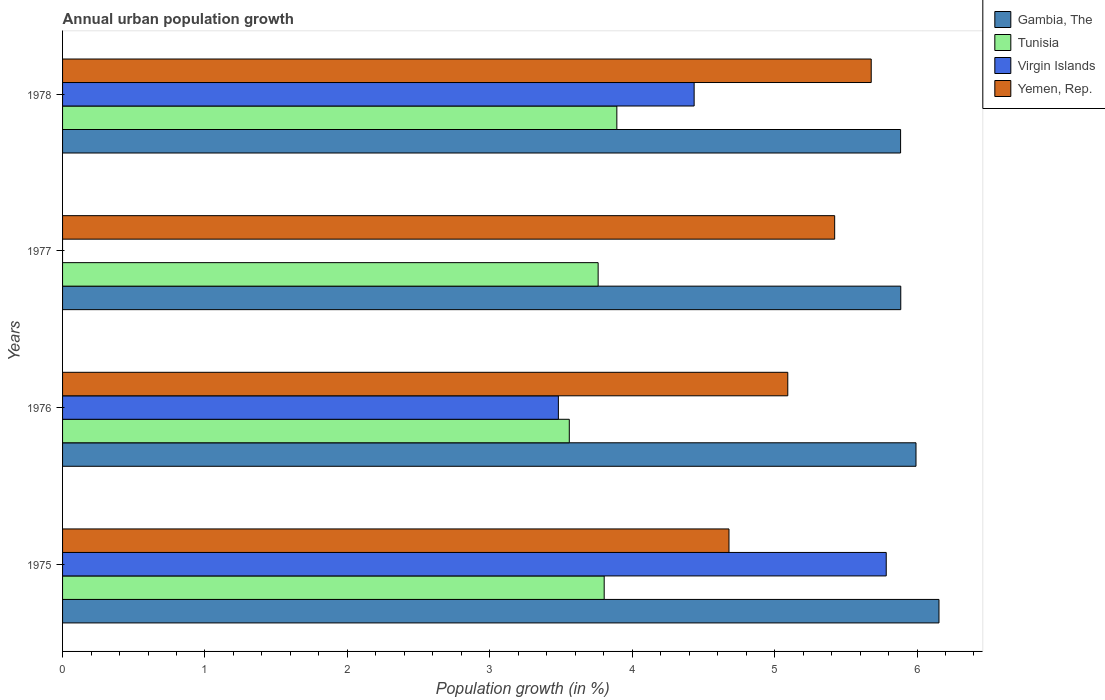Are the number of bars per tick equal to the number of legend labels?
Offer a very short reply. No. How many bars are there on the 1st tick from the top?
Your response must be concise. 4. How many bars are there on the 4th tick from the bottom?
Your answer should be very brief. 4. What is the label of the 4th group of bars from the top?
Ensure brevity in your answer.  1975. What is the percentage of urban population growth in Gambia, The in 1978?
Your response must be concise. 5.88. Across all years, what is the maximum percentage of urban population growth in Tunisia?
Offer a terse response. 3.89. Across all years, what is the minimum percentage of urban population growth in Tunisia?
Give a very brief answer. 3.56. In which year was the percentage of urban population growth in Yemen, Rep. maximum?
Offer a terse response. 1978. What is the total percentage of urban population growth in Gambia, The in the graph?
Keep it short and to the point. 23.92. What is the difference between the percentage of urban population growth in Tunisia in 1975 and that in 1977?
Your answer should be compact. 0.04. What is the difference between the percentage of urban population growth in Virgin Islands in 1978 and the percentage of urban population growth in Yemen, Rep. in 1976?
Give a very brief answer. -0.66. What is the average percentage of urban population growth in Tunisia per year?
Give a very brief answer. 3.75. In the year 1978, what is the difference between the percentage of urban population growth in Yemen, Rep. and percentage of urban population growth in Gambia, The?
Ensure brevity in your answer.  -0.21. In how many years, is the percentage of urban population growth in Yemen, Rep. greater than 6 %?
Ensure brevity in your answer.  0. What is the ratio of the percentage of urban population growth in Gambia, The in 1976 to that in 1977?
Provide a short and direct response. 1.02. Is the percentage of urban population growth in Yemen, Rep. in 1975 less than that in 1978?
Make the answer very short. Yes. What is the difference between the highest and the second highest percentage of urban population growth in Gambia, The?
Ensure brevity in your answer.  0.16. What is the difference between the highest and the lowest percentage of urban population growth in Virgin Islands?
Your answer should be very brief. 5.78. Is the sum of the percentage of urban population growth in Gambia, The in 1977 and 1978 greater than the maximum percentage of urban population growth in Yemen, Rep. across all years?
Your answer should be compact. Yes. Is it the case that in every year, the sum of the percentage of urban population growth in Yemen, Rep. and percentage of urban population growth in Tunisia is greater than the sum of percentage of urban population growth in Gambia, The and percentage of urban population growth in Virgin Islands?
Your answer should be very brief. No. Is it the case that in every year, the sum of the percentage of urban population growth in Yemen, Rep. and percentage of urban population growth in Virgin Islands is greater than the percentage of urban population growth in Gambia, The?
Give a very brief answer. No. Where does the legend appear in the graph?
Make the answer very short. Top right. How many legend labels are there?
Keep it short and to the point. 4. What is the title of the graph?
Provide a short and direct response. Annual urban population growth. What is the label or title of the X-axis?
Your answer should be compact. Population growth (in %). What is the Population growth (in %) of Gambia, The in 1975?
Your answer should be very brief. 6.15. What is the Population growth (in %) of Tunisia in 1975?
Offer a very short reply. 3.8. What is the Population growth (in %) in Virgin Islands in 1975?
Make the answer very short. 5.78. What is the Population growth (in %) of Yemen, Rep. in 1975?
Your answer should be compact. 4.68. What is the Population growth (in %) in Gambia, The in 1976?
Offer a very short reply. 5.99. What is the Population growth (in %) in Tunisia in 1976?
Your answer should be compact. 3.56. What is the Population growth (in %) of Virgin Islands in 1976?
Provide a short and direct response. 3.48. What is the Population growth (in %) in Yemen, Rep. in 1976?
Give a very brief answer. 5.09. What is the Population growth (in %) of Gambia, The in 1977?
Keep it short and to the point. 5.89. What is the Population growth (in %) in Tunisia in 1977?
Your answer should be very brief. 3.76. What is the Population growth (in %) of Virgin Islands in 1977?
Provide a short and direct response. 0. What is the Population growth (in %) of Yemen, Rep. in 1977?
Offer a terse response. 5.42. What is the Population growth (in %) in Gambia, The in 1978?
Your answer should be very brief. 5.88. What is the Population growth (in %) in Tunisia in 1978?
Your answer should be compact. 3.89. What is the Population growth (in %) of Virgin Islands in 1978?
Your response must be concise. 4.44. What is the Population growth (in %) of Yemen, Rep. in 1978?
Offer a terse response. 5.68. Across all years, what is the maximum Population growth (in %) of Gambia, The?
Provide a succinct answer. 6.15. Across all years, what is the maximum Population growth (in %) of Tunisia?
Ensure brevity in your answer.  3.89. Across all years, what is the maximum Population growth (in %) in Virgin Islands?
Your answer should be very brief. 5.78. Across all years, what is the maximum Population growth (in %) of Yemen, Rep.?
Your response must be concise. 5.68. Across all years, what is the minimum Population growth (in %) in Gambia, The?
Offer a terse response. 5.88. Across all years, what is the minimum Population growth (in %) in Tunisia?
Your answer should be compact. 3.56. Across all years, what is the minimum Population growth (in %) of Virgin Islands?
Provide a succinct answer. 0. Across all years, what is the minimum Population growth (in %) of Yemen, Rep.?
Provide a short and direct response. 4.68. What is the total Population growth (in %) of Gambia, The in the graph?
Provide a short and direct response. 23.92. What is the total Population growth (in %) in Tunisia in the graph?
Your answer should be compact. 15.02. What is the total Population growth (in %) of Virgin Islands in the graph?
Ensure brevity in your answer.  13.7. What is the total Population growth (in %) of Yemen, Rep. in the graph?
Provide a succinct answer. 20.87. What is the difference between the Population growth (in %) of Gambia, The in 1975 and that in 1976?
Provide a succinct answer. 0.16. What is the difference between the Population growth (in %) in Tunisia in 1975 and that in 1976?
Ensure brevity in your answer.  0.24. What is the difference between the Population growth (in %) in Virgin Islands in 1975 and that in 1976?
Ensure brevity in your answer.  2.3. What is the difference between the Population growth (in %) of Yemen, Rep. in 1975 and that in 1976?
Provide a short and direct response. -0.41. What is the difference between the Population growth (in %) of Gambia, The in 1975 and that in 1977?
Your answer should be compact. 0.27. What is the difference between the Population growth (in %) in Tunisia in 1975 and that in 1977?
Offer a terse response. 0.04. What is the difference between the Population growth (in %) of Yemen, Rep. in 1975 and that in 1977?
Provide a succinct answer. -0.74. What is the difference between the Population growth (in %) of Gambia, The in 1975 and that in 1978?
Give a very brief answer. 0.27. What is the difference between the Population growth (in %) in Tunisia in 1975 and that in 1978?
Make the answer very short. -0.09. What is the difference between the Population growth (in %) of Virgin Islands in 1975 and that in 1978?
Offer a very short reply. 1.35. What is the difference between the Population growth (in %) of Yemen, Rep. in 1975 and that in 1978?
Make the answer very short. -1. What is the difference between the Population growth (in %) of Gambia, The in 1976 and that in 1977?
Your answer should be compact. 0.11. What is the difference between the Population growth (in %) in Tunisia in 1976 and that in 1977?
Your answer should be compact. -0.2. What is the difference between the Population growth (in %) of Yemen, Rep. in 1976 and that in 1977?
Your response must be concise. -0.33. What is the difference between the Population growth (in %) of Gambia, The in 1976 and that in 1978?
Offer a very short reply. 0.11. What is the difference between the Population growth (in %) of Tunisia in 1976 and that in 1978?
Keep it short and to the point. -0.33. What is the difference between the Population growth (in %) in Virgin Islands in 1976 and that in 1978?
Ensure brevity in your answer.  -0.95. What is the difference between the Population growth (in %) of Yemen, Rep. in 1976 and that in 1978?
Give a very brief answer. -0.59. What is the difference between the Population growth (in %) in Gambia, The in 1977 and that in 1978?
Provide a short and direct response. 0. What is the difference between the Population growth (in %) of Tunisia in 1977 and that in 1978?
Your response must be concise. -0.13. What is the difference between the Population growth (in %) in Yemen, Rep. in 1977 and that in 1978?
Your answer should be compact. -0.26. What is the difference between the Population growth (in %) in Gambia, The in 1975 and the Population growth (in %) in Tunisia in 1976?
Provide a short and direct response. 2.6. What is the difference between the Population growth (in %) of Gambia, The in 1975 and the Population growth (in %) of Virgin Islands in 1976?
Offer a terse response. 2.67. What is the difference between the Population growth (in %) of Gambia, The in 1975 and the Population growth (in %) of Yemen, Rep. in 1976?
Your answer should be very brief. 1.06. What is the difference between the Population growth (in %) in Tunisia in 1975 and the Population growth (in %) in Virgin Islands in 1976?
Your response must be concise. 0.32. What is the difference between the Population growth (in %) of Tunisia in 1975 and the Population growth (in %) of Yemen, Rep. in 1976?
Your answer should be very brief. -1.29. What is the difference between the Population growth (in %) in Virgin Islands in 1975 and the Population growth (in %) in Yemen, Rep. in 1976?
Offer a terse response. 0.69. What is the difference between the Population growth (in %) of Gambia, The in 1975 and the Population growth (in %) of Tunisia in 1977?
Your response must be concise. 2.39. What is the difference between the Population growth (in %) in Gambia, The in 1975 and the Population growth (in %) in Yemen, Rep. in 1977?
Provide a succinct answer. 0.73. What is the difference between the Population growth (in %) in Tunisia in 1975 and the Population growth (in %) in Yemen, Rep. in 1977?
Provide a short and direct response. -1.62. What is the difference between the Population growth (in %) of Virgin Islands in 1975 and the Population growth (in %) of Yemen, Rep. in 1977?
Provide a succinct answer. 0.36. What is the difference between the Population growth (in %) of Gambia, The in 1975 and the Population growth (in %) of Tunisia in 1978?
Ensure brevity in your answer.  2.26. What is the difference between the Population growth (in %) in Gambia, The in 1975 and the Population growth (in %) in Virgin Islands in 1978?
Offer a terse response. 1.72. What is the difference between the Population growth (in %) of Gambia, The in 1975 and the Population growth (in %) of Yemen, Rep. in 1978?
Ensure brevity in your answer.  0.48. What is the difference between the Population growth (in %) of Tunisia in 1975 and the Population growth (in %) of Virgin Islands in 1978?
Provide a succinct answer. -0.63. What is the difference between the Population growth (in %) of Tunisia in 1975 and the Population growth (in %) of Yemen, Rep. in 1978?
Your answer should be very brief. -1.88. What is the difference between the Population growth (in %) of Virgin Islands in 1975 and the Population growth (in %) of Yemen, Rep. in 1978?
Ensure brevity in your answer.  0.11. What is the difference between the Population growth (in %) of Gambia, The in 1976 and the Population growth (in %) of Tunisia in 1977?
Provide a short and direct response. 2.23. What is the difference between the Population growth (in %) in Gambia, The in 1976 and the Population growth (in %) in Yemen, Rep. in 1977?
Keep it short and to the point. 0.57. What is the difference between the Population growth (in %) in Tunisia in 1976 and the Population growth (in %) in Yemen, Rep. in 1977?
Offer a terse response. -1.86. What is the difference between the Population growth (in %) of Virgin Islands in 1976 and the Population growth (in %) of Yemen, Rep. in 1977?
Offer a terse response. -1.94. What is the difference between the Population growth (in %) of Gambia, The in 1976 and the Population growth (in %) of Tunisia in 1978?
Your answer should be very brief. 2.1. What is the difference between the Population growth (in %) in Gambia, The in 1976 and the Population growth (in %) in Virgin Islands in 1978?
Give a very brief answer. 1.56. What is the difference between the Population growth (in %) in Gambia, The in 1976 and the Population growth (in %) in Yemen, Rep. in 1978?
Offer a very short reply. 0.31. What is the difference between the Population growth (in %) of Tunisia in 1976 and the Population growth (in %) of Virgin Islands in 1978?
Offer a terse response. -0.88. What is the difference between the Population growth (in %) of Tunisia in 1976 and the Population growth (in %) of Yemen, Rep. in 1978?
Offer a very short reply. -2.12. What is the difference between the Population growth (in %) of Virgin Islands in 1976 and the Population growth (in %) of Yemen, Rep. in 1978?
Make the answer very short. -2.2. What is the difference between the Population growth (in %) in Gambia, The in 1977 and the Population growth (in %) in Tunisia in 1978?
Offer a terse response. 1.99. What is the difference between the Population growth (in %) in Gambia, The in 1977 and the Population growth (in %) in Virgin Islands in 1978?
Your answer should be compact. 1.45. What is the difference between the Population growth (in %) in Gambia, The in 1977 and the Population growth (in %) in Yemen, Rep. in 1978?
Offer a very short reply. 0.21. What is the difference between the Population growth (in %) of Tunisia in 1977 and the Population growth (in %) of Virgin Islands in 1978?
Offer a very short reply. -0.67. What is the difference between the Population growth (in %) of Tunisia in 1977 and the Population growth (in %) of Yemen, Rep. in 1978?
Make the answer very short. -1.92. What is the average Population growth (in %) of Gambia, The per year?
Offer a very short reply. 5.98. What is the average Population growth (in %) in Tunisia per year?
Your answer should be compact. 3.75. What is the average Population growth (in %) of Virgin Islands per year?
Offer a very short reply. 3.43. What is the average Population growth (in %) of Yemen, Rep. per year?
Your answer should be compact. 5.22. In the year 1975, what is the difference between the Population growth (in %) of Gambia, The and Population growth (in %) of Tunisia?
Your answer should be compact. 2.35. In the year 1975, what is the difference between the Population growth (in %) of Gambia, The and Population growth (in %) of Virgin Islands?
Provide a succinct answer. 0.37. In the year 1975, what is the difference between the Population growth (in %) of Gambia, The and Population growth (in %) of Yemen, Rep.?
Make the answer very short. 1.47. In the year 1975, what is the difference between the Population growth (in %) of Tunisia and Population growth (in %) of Virgin Islands?
Give a very brief answer. -1.98. In the year 1975, what is the difference between the Population growth (in %) of Tunisia and Population growth (in %) of Yemen, Rep.?
Ensure brevity in your answer.  -0.88. In the year 1975, what is the difference between the Population growth (in %) in Virgin Islands and Population growth (in %) in Yemen, Rep.?
Provide a succinct answer. 1.1. In the year 1976, what is the difference between the Population growth (in %) in Gambia, The and Population growth (in %) in Tunisia?
Your answer should be very brief. 2.43. In the year 1976, what is the difference between the Population growth (in %) in Gambia, The and Population growth (in %) in Virgin Islands?
Provide a short and direct response. 2.51. In the year 1976, what is the difference between the Population growth (in %) in Gambia, The and Population growth (in %) in Yemen, Rep.?
Ensure brevity in your answer.  0.9. In the year 1976, what is the difference between the Population growth (in %) in Tunisia and Population growth (in %) in Virgin Islands?
Keep it short and to the point. 0.08. In the year 1976, what is the difference between the Population growth (in %) of Tunisia and Population growth (in %) of Yemen, Rep.?
Your response must be concise. -1.53. In the year 1976, what is the difference between the Population growth (in %) of Virgin Islands and Population growth (in %) of Yemen, Rep.?
Make the answer very short. -1.61. In the year 1977, what is the difference between the Population growth (in %) in Gambia, The and Population growth (in %) in Tunisia?
Provide a short and direct response. 2.12. In the year 1977, what is the difference between the Population growth (in %) of Gambia, The and Population growth (in %) of Yemen, Rep.?
Offer a very short reply. 0.46. In the year 1977, what is the difference between the Population growth (in %) in Tunisia and Population growth (in %) in Yemen, Rep.?
Make the answer very short. -1.66. In the year 1978, what is the difference between the Population growth (in %) in Gambia, The and Population growth (in %) in Tunisia?
Your response must be concise. 1.99. In the year 1978, what is the difference between the Population growth (in %) in Gambia, The and Population growth (in %) in Virgin Islands?
Offer a very short reply. 1.45. In the year 1978, what is the difference between the Population growth (in %) in Gambia, The and Population growth (in %) in Yemen, Rep.?
Give a very brief answer. 0.21. In the year 1978, what is the difference between the Population growth (in %) of Tunisia and Population growth (in %) of Virgin Islands?
Ensure brevity in your answer.  -0.54. In the year 1978, what is the difference between the Population growth (in %) of Tunisia and Population growth (in %) of Yemen, Rep.?
Offer a very short reply. -1.79. In the year 1978, what is the difference between the Population growth (in %) in Virgin Islands and Population growth (in %) in Yemen, Rep.?
Offer a terse response. -1.24. What is the ratio of the Population growth (in %) of Gambia, The in 1975 to that in 1976?
Offer a terse response. 1.03. What is the ratio of the Population growth (in %) in Tunisia in 1975 to that in 1976?
Your answer should be very brief. 1.07. What is the ratio of the Population growth (in %) of Virgin Islands in 1975 to that in 1976?
Your response must be concise. 1.66. What is the ratio of the Population growth (in %) in Yemen, Rep. in 1975 to that in 1976?
Give a very brief answer. 0.92. What is the ratio of the Population growth (in %) of Gambia, The in 1975 to that in 1977?
Your response must be concise. 1.05. What is the ratio of the Population growth (in %) in Tunisia in 1975 to that in 1977?
Offer a very short reply. 1.01. What is the ratio of the Population growth (in %) of Yemen, Rep. in 1975 to that in 1977?
Give a very brief answer. 0.86. What is the ratio of the Population growth (in %) in Gambia, The in 1975 to that in 1978?
Offer a very short reply. 1.05. What is the ratio of the Population growth (in %) in Tunisia in 1975 to that in 1978?
Your answer should be very brief. 0.98. What is the ratio of the Population growth (in %) in Virgin Islands in 1975 to that in 1978?
Your response must be concise. 1.3. What is the ratio of the Population growth (in %) of Yemen, Rep. in 1975 to that in 1978?
Provide a succinct answer. 0.82. What is the ratio of the Population growth (in %) in Gambia, The in 1976 to that in 1977?
Make the answer very short. 1.02. What is the ratio of the Population growth (in %) in Tunisia in 1976 to that in 1977?
Provide a short and direct response. 0.95. What is the ratio of the Population growth (in %) of Yemen, Rep. in 1976 to that in 1977?
Your response must be concise. 0.94. What is the ratio of the Population growth (in %) in Gambia, The in 1976 to that in 1978?
Provide a succinct answer. 1.02. What is the ratio of the Population growth (in %) of Tunisia in 1976 to that in 1978?
Offer a terse response. 0.91. What is the ratio of the Population growth (in %) of Virgin Islands in 1976 to that in 1978?
Your answer should be compact. 0.79. What is the ratio of the Population growth (in %) in Yemen, Rep. in 1976 to that in 1978?
Provide a short and direct response. 0.9. What is the ratio of the Population growth (in %) in Gambia, The in 1977 to that in 1978?
Offer a terse response. 1. What is the ratio of the Population growth (in %) of Tunisia in 1977 to that in 1978?
Ensure brevity in your answer.  0.97. What is the ratio of the Population growth (in %) of Yemen, Rep. in 1977 to that in 1978?
Ensure brevity in your answer.  0.95. What is the difference between the highest and the second highest Population growth (in %) of Gambia, The?
Offer a very short reply. 0.16. What is the difference between the highest and the second highest Population growth (in %) in Tunisia?
Your answer should be very brief. 0.09. What is the difference between the highest and the second highest Population growth (in %) of Virgin Islands?
Your answer should be very brief. 1.35. What is the difference between the highest and the second highest Population growth (in %) of Yemen, Rep.?
Ensure brevity in your answer.  0.26. What is the difference between the highest and the lowest Population growth (in %) of Gambia, The?
Keep it short and to the point. 0.27. What is the difference between the highest and the lowest Population growth (in %) in Tunisia?
Your answer should be very brief. 0.33. What is the difference between the highest and the lowest Population growth (in %) in Virgin Islands?
Ensure brevity in your answer.  5.78. 